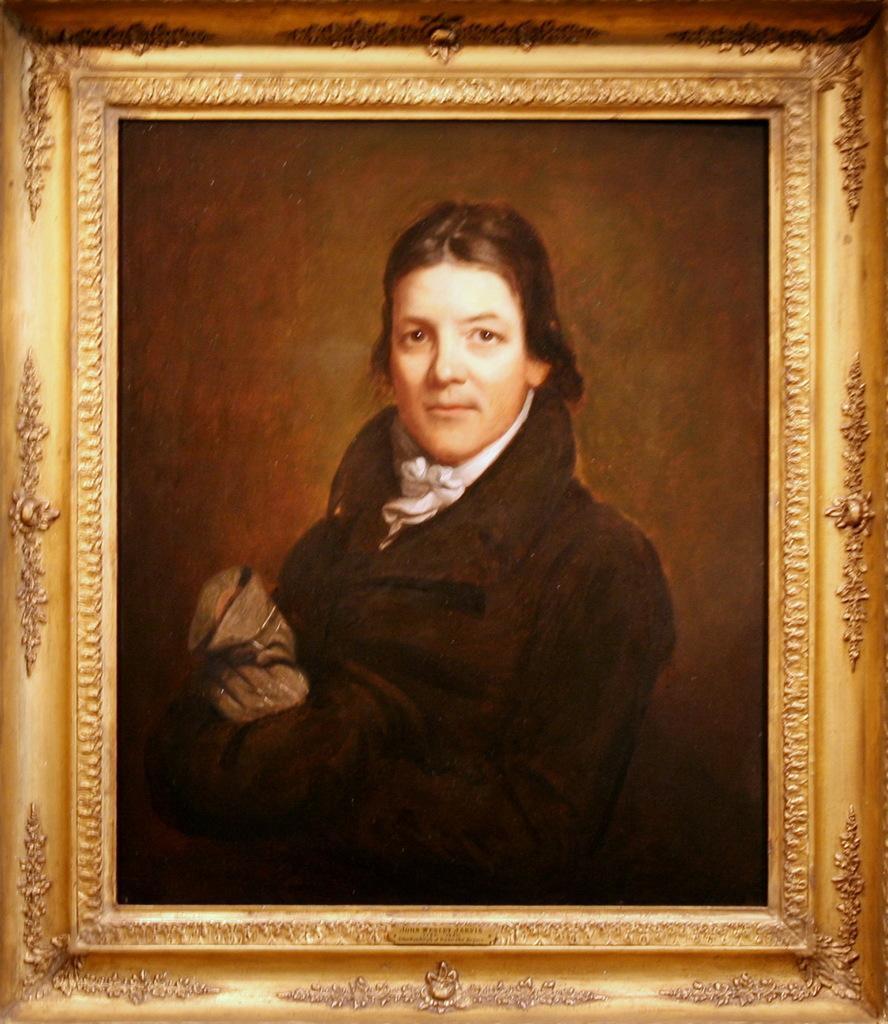Describe this image in one or two sentences. In this image there is a depiction of a person in the photo frame. 